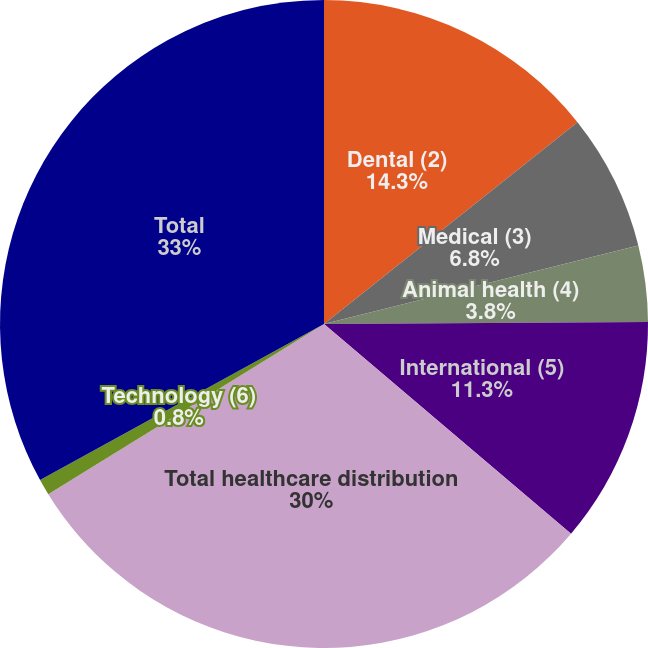Convert chart. <chart><loc_0><loc_0><loc_500><loc_500><pie_chart><fcel>Dental (2)<fcel>Medical (3)<fcel>Animal health (4)<fcel>International (5)<fcel>Total healthcare distribution<fcel>Technology (6)<fcel>Total<nl><fcel>14.3%<fcel>6.8%<fcel>3.8%<fcel>11.3%<fcel>30.0%<fcel>0.8%<fcel>33.0%<nl></chart> 